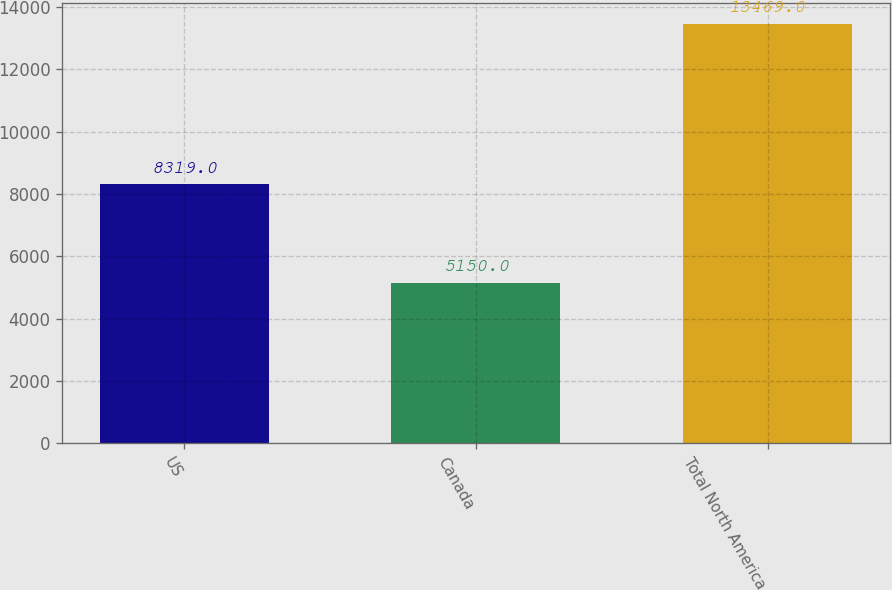Convert chart to OTSL. <chart><loc_0><loc_0><loc_500><loc_500><bar_chart><fcel>US<fcel>Canada<fcel>Total North America<nl><fcel>8319<fcel>5150<fcel>13469<nl></chart> 